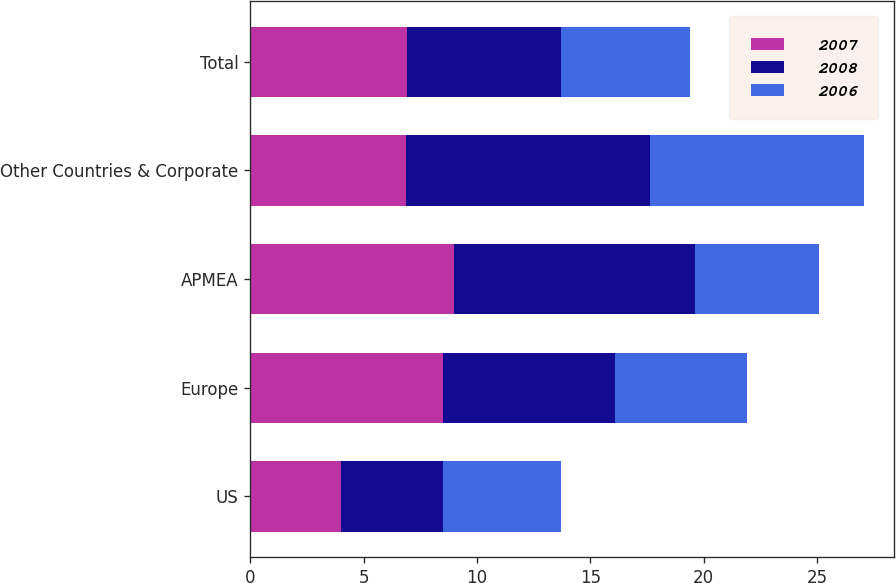Convert chart. <chart><loc_0><loc_0><loc_500><loc_500><stacked_bar_chart><ecel><fcel>US<fcel>Europe<fcel>APMEA<fcel>Other Countries & Corporate<fcel>Total<nl><fcel>2007<fcel>4<fcel>8.5<fcel>9<fcel>6.85<fcel>6.9<nl><fcel>2008<fcel>4.5<fcel>7.6<fcel>10.6<fcel>10.8<fcel>6.8<nl><fcel>2006<fcel>5.2<fcel>5.8<fcel>5.5<fcel>9.4<fcel>5.7<nl></chart> 